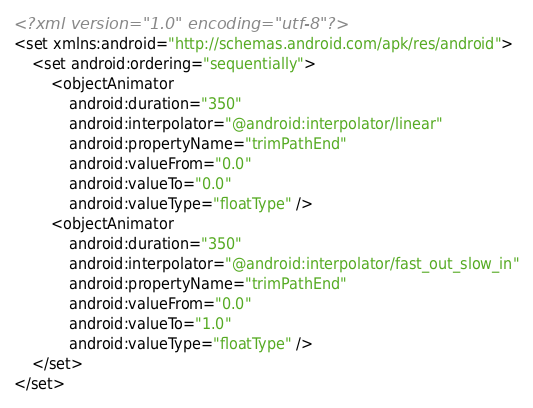<code> <loc_0><loc_0><loc_500><loc_500><_XML_><?xml version="1.0" encoding="utf-8"?>
<set xmlns:android="http://schemas.android.com/apk/res/android">
    <set android:ordering="sequentially">
        <objectAnimator
            android:duration="350"
            android:interpolator="@android:interpolator/linear"
            android:propertyName="trimPathEnd"
            android:valueFrom="0.0"
            android:valueTo="0.0"
            android:valueType="floatType" />
        <objectAnimator
            android:duration="350"
            android:interpolator="@android:interpolator/fast_out_slow_in"
            android:propertyName="trimPathEnd"
            android:valueFrom="0.0"
            android:valueTo="1.0"
            android:valueType="floatType" />
    </set>
</set>
</code> 